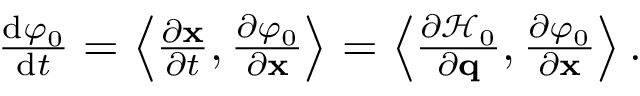Convert formula to latex. <formula><loc_0><loc_0><loc_500><loc_500>\begin{array} { r } { \frac { d \varphi _ { 0 } } { d t } = \left \langle \frac { \partial x } { \partial t } , \frac { \partial \varphi _ { 0 } } { \partial x } \right \rangle = \left \langle \frac { \partial \mathcal { H } _ { 0 } } { \partial q } , \frac { \partial \varphi _ { 0 } } { \partial x } \right \rangle . } \end{array}</formula> 